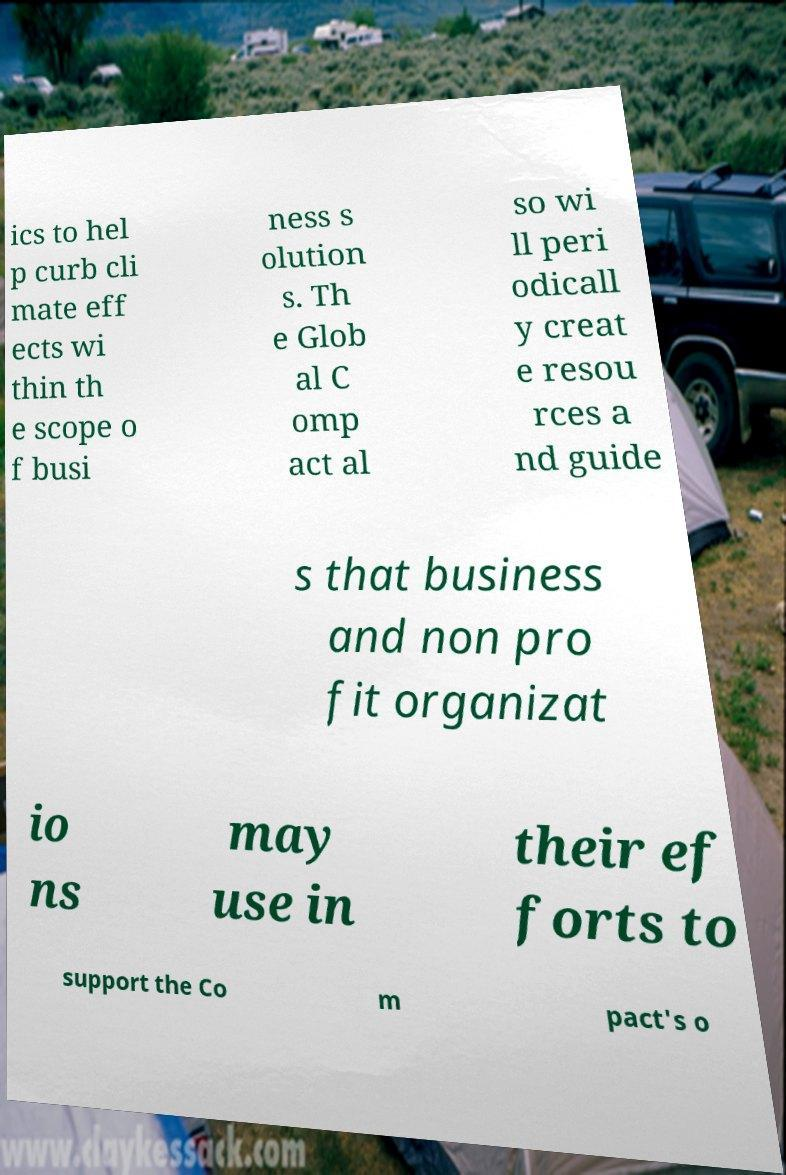Can you read and provide the text displayed in the image?This photo seems to have some interesting text. Can you extract and type it out for me? ics to hel p curb cli mate eff ects wi thin th e scope o f busi ness s olution s. Th e Glob al C omp act al so wi ll peri odicall y creat e resou rces a nd guide s that business and non pro fit organizat io ns may use in their ef forts to support the Co m pact's o 